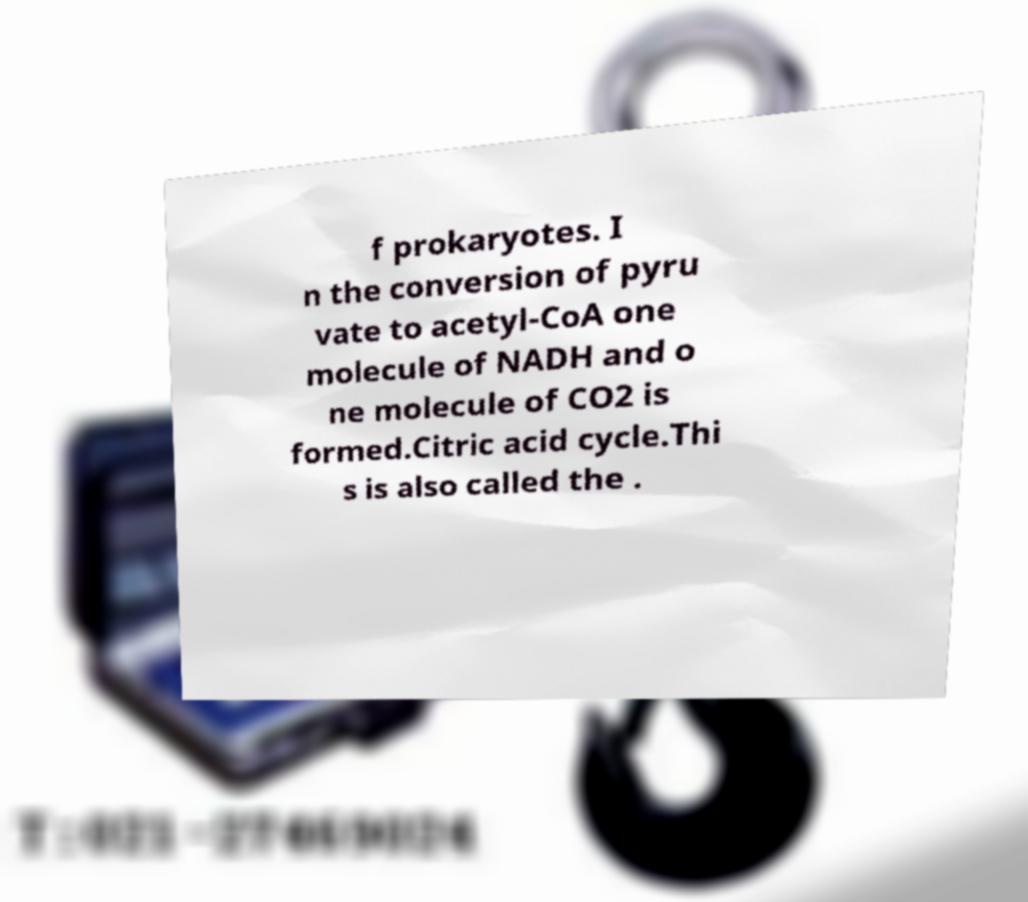Please identify and transcribe the text found in this image. f prokaryotes. I n the conversion of pyru vate to acetyl-CoA one molecule of NADH and o ne molecule of CO2 is formed.Citric acid cycle.Thi s is also called the . 